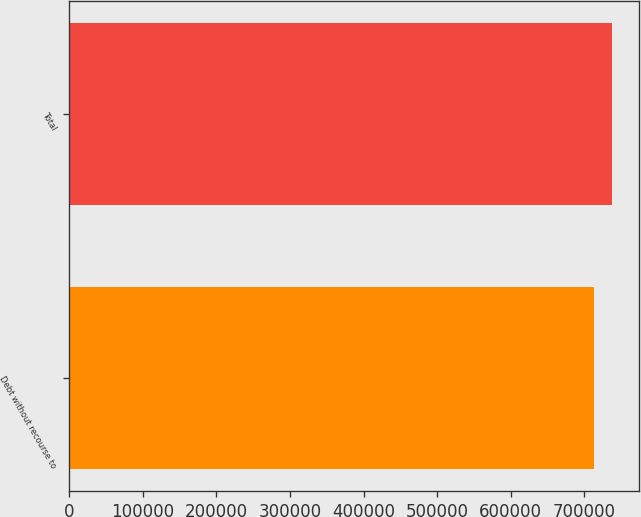<chart> <loc_0><loc_0><loc_500><loc_500><bar_chart><fcel>Debt without recourse to<fcel>Total<nl><fcel>713274<fcel>737755<nl></chart> 